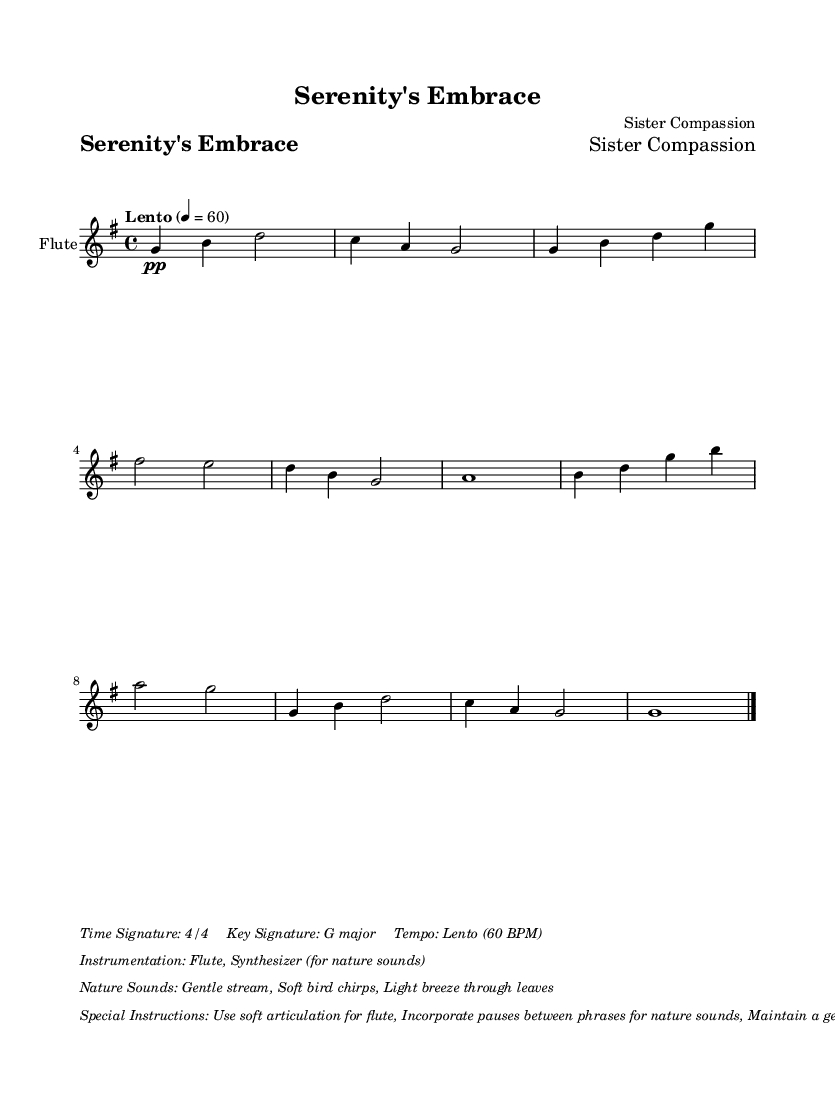What is the title of this music? The title is found in the header section of the score, which states "Serenity's Embrace."
Answer: Serenity's Embrace What is the key signature of this music? The key signature can be determined from the notation at the beginning of the staff, which indicates G major, having one sharp (F#).
Answer: G major What is the tempo marking given in this composition? The tempo is indicated at the beginning of the score with the term "Lento," which signifies a slow pace.
Answer: Lento What instruments are used in this piece? The instrumentation is specified in the markup section, stating "Flute, Synthesizer (for nature sounds)."
Answer: Flute, Synthesizer What is the time signature of this music? The time signature is displayed at the start of the score, represented as 4/4, meaning there are four beats in a measure.
Answer: 4/4 How should the flute be articulated according to the instructions? The special instructions indicate to "Use soft articulation for flute," emphasizing the gentleness required in performance.
Answer: Soft articulation Why are pauses emphasized between phrases in this music? The special instructions express the need for pauses between phrases for nature sounds, which creates a calming and reflective atmosphere during counseling sessions.
Answer: To enhance calming atmosphere 